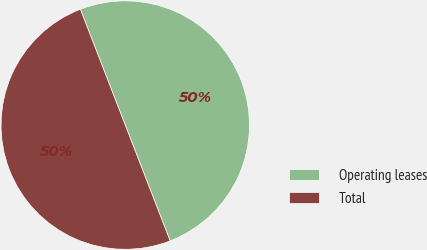<chart> <loc_0><loc_0><loc_500><loc_500><pie_chart><fcel>Operating leases<fcel>Total<nl><fcel>50.0%<fcel>50.0%<nl></chart> 